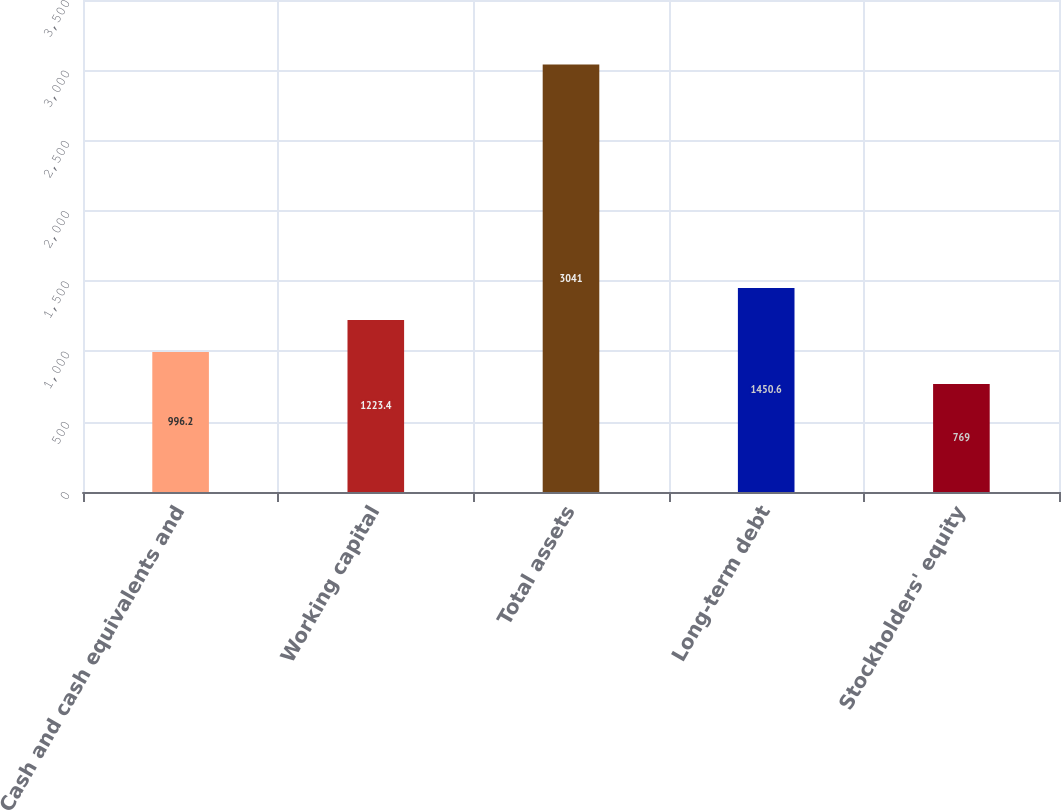<chart> <loc_0><loc_0><loc_500><loc_500><bar_chart><fcel>Cash and cash equivalents and<fcel>Working capital<fcel>Total assets<fcel>Long-term debt<fcel>Stockholders' equity<nl><fcel>996.2<fcel>1223.4<fcel>3041<fcel>1450.6<fcel>769<nl></chart> 